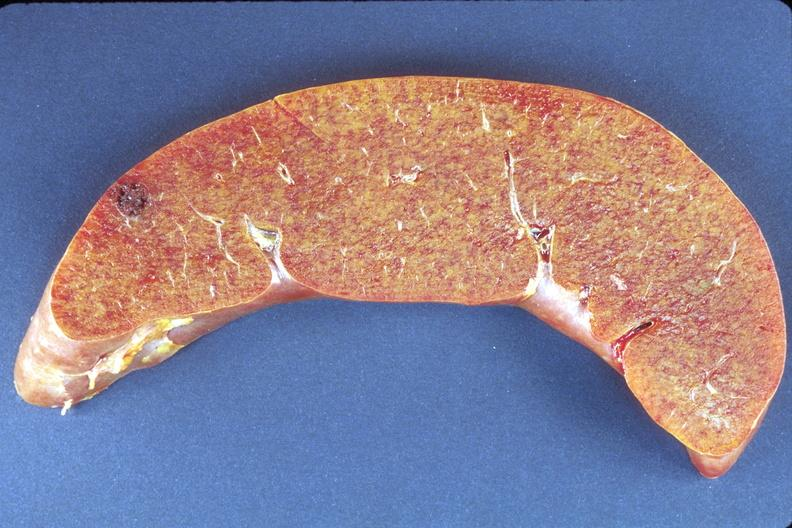does meningioma show liver, amyloidosis?
Answer the question using a single word or phrase. No 